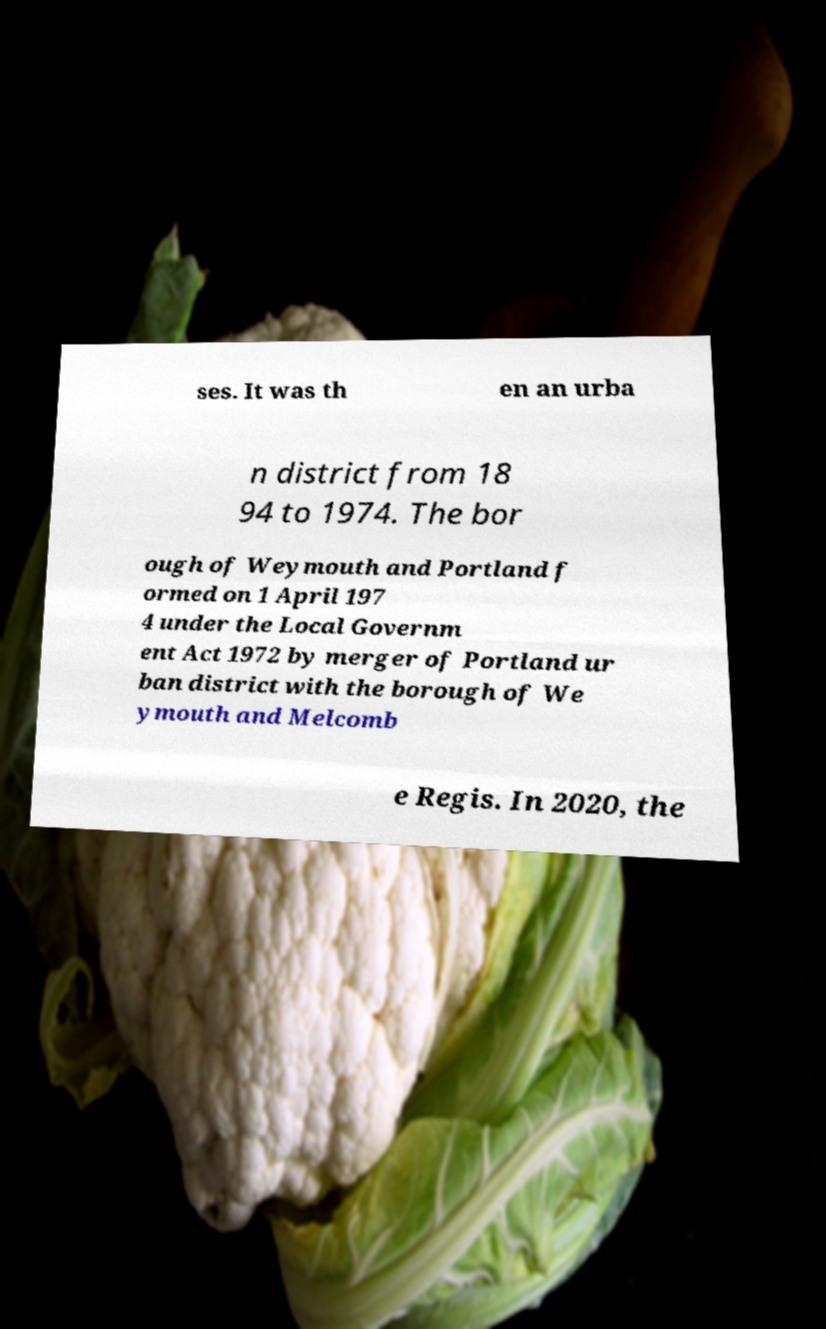Can you accurately transcribe the text from the provided image for me? ses. It was th en an urba n district from 18 94 to 1974. The bor ough of Weymouth and Portland f ormed on 1 April 197 4 under the Local Governm ent Act 1972 by merger of Portland ur ban district with the borough of We ymouth and Melcomb e Regis. In 2020, the 